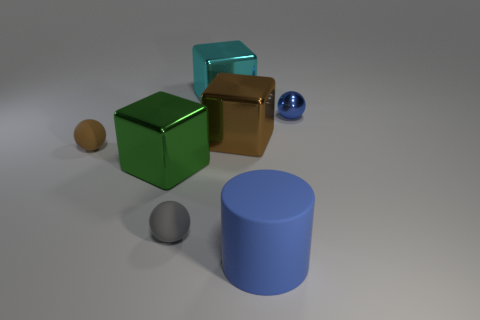Is the number of large cyan metal cubes that are right of the blue sphere greater than the number of cyan metal cubes?
Give a very brief answer. No. There is a brown thing on the right side of the big cyan cube; is it the same shape as the green metallic object?
Offer a very short reply. Yes. Are there any tiny blue things of the same shape as the large blue object?
Provide a succinct answer. No. What number of objects are either blue things that are in front of the big brown shiny thing or tiny red shiny cubes?
Your answer should be compact. 1. Is the number of green cubes greater than the number of objects?
Provide a succinct answer. No. Are there any other blue rubber cylinders that have the same size as the matte cylinder?
Make the answer very short. No. How many objects are either big objects that are on the right side of the green object or small objects that are behind the small brown thing?
Your answer should be compact. 4. There is a big object that is behind the metallic thing to the right of the large cylinder; what is its color?
Offer a terse response. Cyan. What color is the other sphere that is made of the same material as the brown sphere?
Ensure brevity in your answer.  Gray. How many large matte things have the same color as the big cylinder?
Your answer should be very brief. 0. 